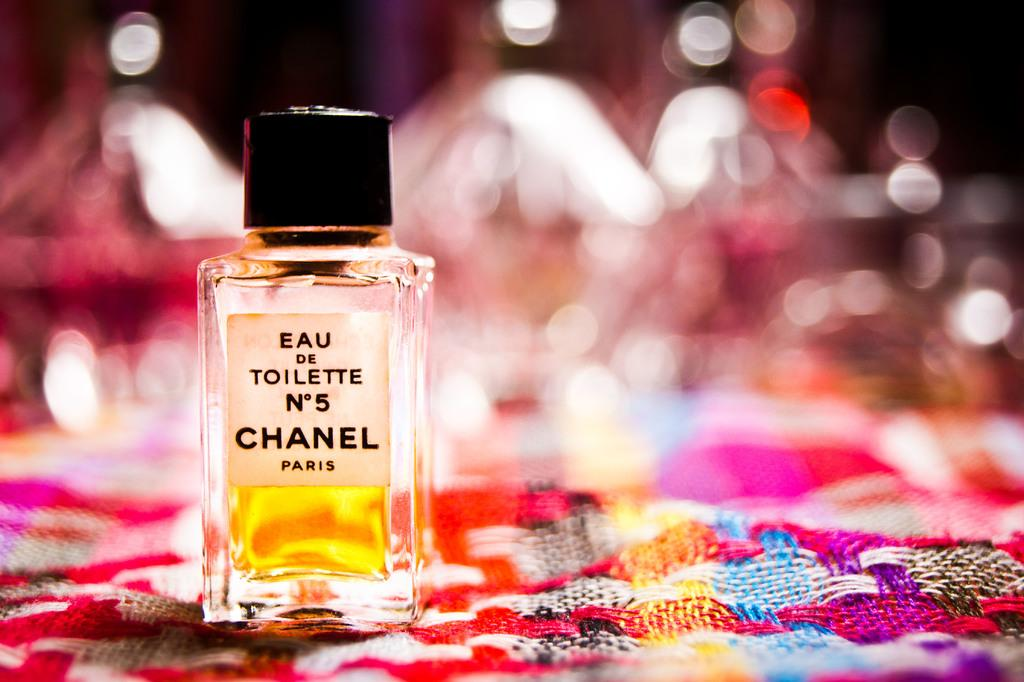<image>
Relay a brief, clear account of the picture shown. A full bottle of Chanel No. 5 on display 